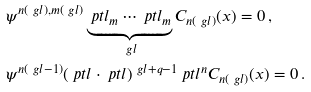Convert formula to latex. <formula><loc_0><loc_0><loc_500><loc_500>& \psi ^ { n ( \ g l ) , m ( \ g l ) } \underbrace { \ p t l _ { m } \cdots \ p t l _ { m } } _ { \ g l } C _ { n ( \ g l ) } ( x ) = 0 \, , \\ & \psi ^ { n ( \ g l - 1 ) } ( \ p t l \cdot \ p t l ) ^ { \ g l + q - 1 } \ p t l ^ { n } C _ { n ( \ g l ) } ( x ) = 0 \, .</formula> 